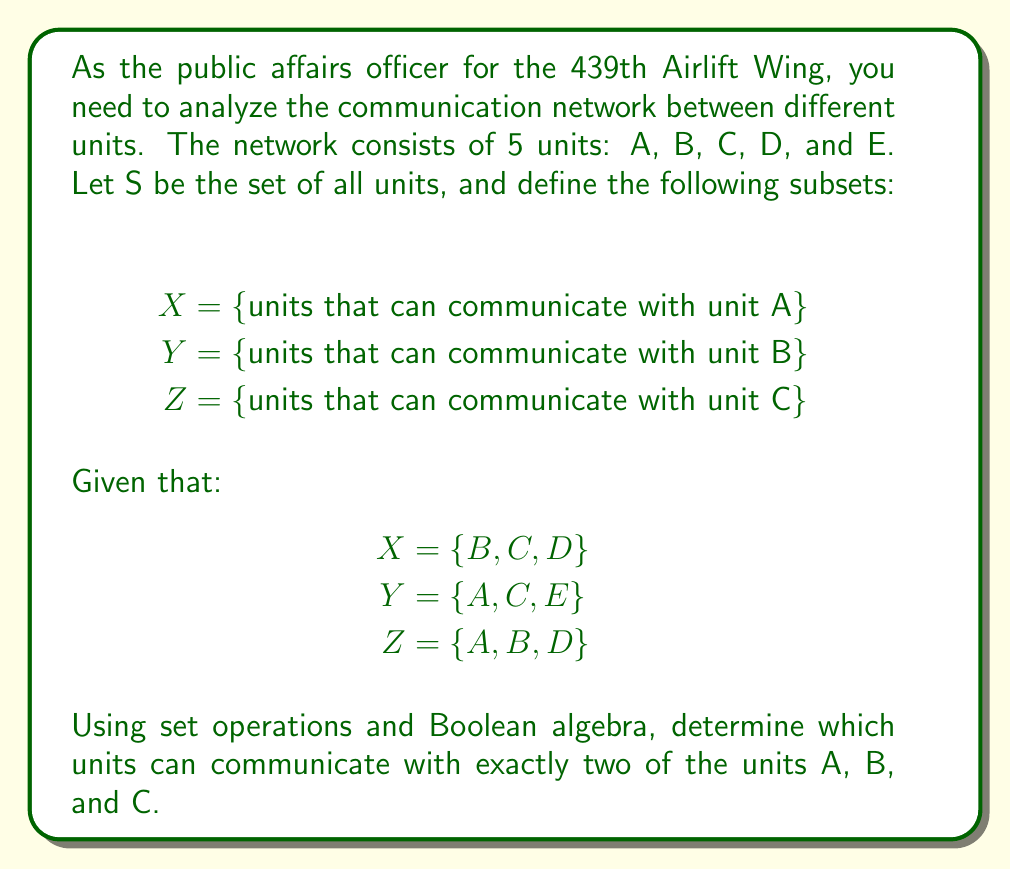Solve this math problem. To solve this problem, we'll use set theory and Boolean algebra:

1. First, let's define the universal set S = {A, B, C, D, E}

2. We need to find units that can communicate with exactly two of A, B, and C. This can be expressed as:

   $$(X \cap Y \cap Z') \cup (X \cap Y' \cap Z) \cup (X' \cap Y \cap Z)$$

   Where $X'$, $Y'$, and $Z'$ represent the complements of X, Y, and Z respectively.

3. Let's calculate the complements:
   $X' = \{A, E\}$
   $Y' = \{B, D\}$
   $Z' = \{C, E\}$

4. Now, let's evaluate each part of the union:

   a) $X \cap Y \cap Z' = \{C\} \cap \{C, E\} = \{C\}$
   b) $X \cap Y' \cap Z = \{D\} \cap \{A, D\} = \{D\}$
   c) $X' \cap Y \cap Z = \{A\} \cap \{A\} = \{A\}$

5. The final result is the union of these sets:

   $\{C\} \cup \{D\} \cup \{A\} = \{A, C, D\}$

Therefore, units A, C, and D can communicate with exactly two of the units A, B, and C.
Answer: The units that can communicate with exactly two of A, B, and C are: A, C, and D. 